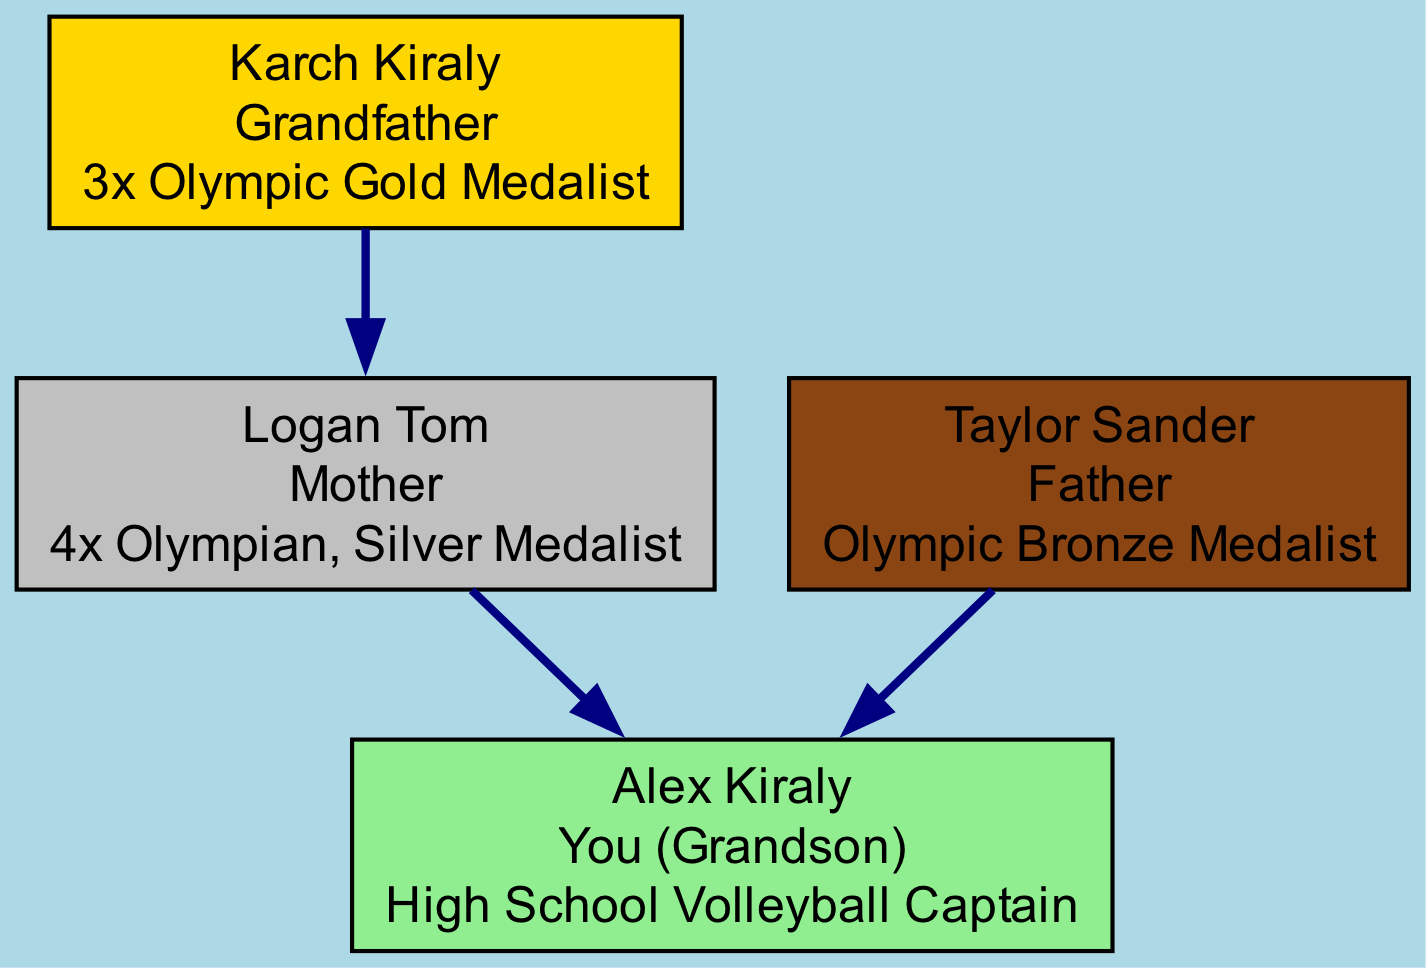What is the achievement of Karch Kiraly? Karch Kiraly is listed in the diagram with the achievement "3x Olympic Gold Medalist." This information is found directly on the node representing him.
Answer: 3x Olympic Gold Medalist Who is the mother in the family tree? The diagram clearly identifies Logan Tom as the mother, as denoted in her role on the node and her position in relation to the other members.
Answer: Logan Tom How many Olympic medals does Taylor Sander have? The diagram specifies that Taylor Sander is an "Olympic Bronze Medalist," which means he has won one Olympic medal, specifically a bronze.
Answer: 1 Which family member has the title of High School Volleyball Captain? The node representing Alex Kiraly states that he is the "High School Volleyball Captain." This title is explicitly mentioned under his achievement in the diagram.
Answer: High School Volleyball Captain What type of medal does Logan Tom have? According to the information on her node, Logan Tom has a "Silver Medal" as part of her achievements as an Olympian. The mention of "Silver Medalist" signifies her type of medal.
Answer: Silver Who are the parents of Alex Kiraly? The directed edges in the diagram indicate the relationships, showing that both Logan Tom and Taylor Sander are connected to Alex Kiraly, which identifies them as his parents.
Answer: Logan Tom and Taylor Sander How many generations are represented in the family tree? The diagram includes Karch Kiraly (grandfather), Logan Tom and Taylor Sander (parents), and Alex Kiraly (grandson), which encompasses three generations.
Answer: 3 Is there an Olympic Gold Medalist in the family? Karch Kiraly is identified in the diagram as a "3x Olympic Gold Medalist," which confirms that there is an Olympic Gold Medalist in the family lineage.
Answer: Yes What is the relationship between Karch Kiraly and Alex Kiraly? The directed edge from Karch Kiraly to Logan Tom (his daughter) and then to Alex Kiraly (his grandson) shows that Karch Kiraly is the grandfather of Alex Kiraly.
Answer: Grandfather Which achievement is directly related to the grandson? The diagram highlights that Alex Kiraly is the "High School Volleyball Captain," which is his specific achievement as listed on his node.
Answer: High School Volleyball Captain 